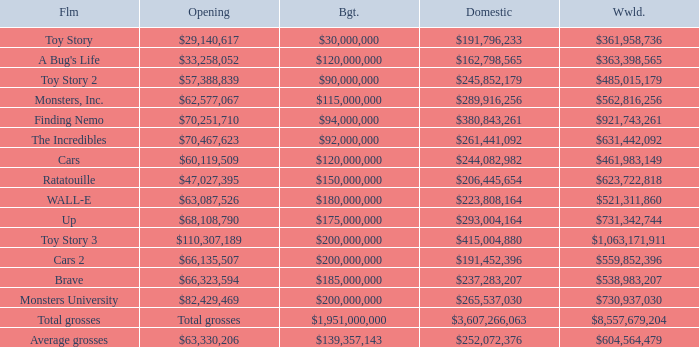WHAT IS THE BUDGET WHEN THE WORLDWIDE BOX OFFICE IS $363,398,565? $120,000,000. 